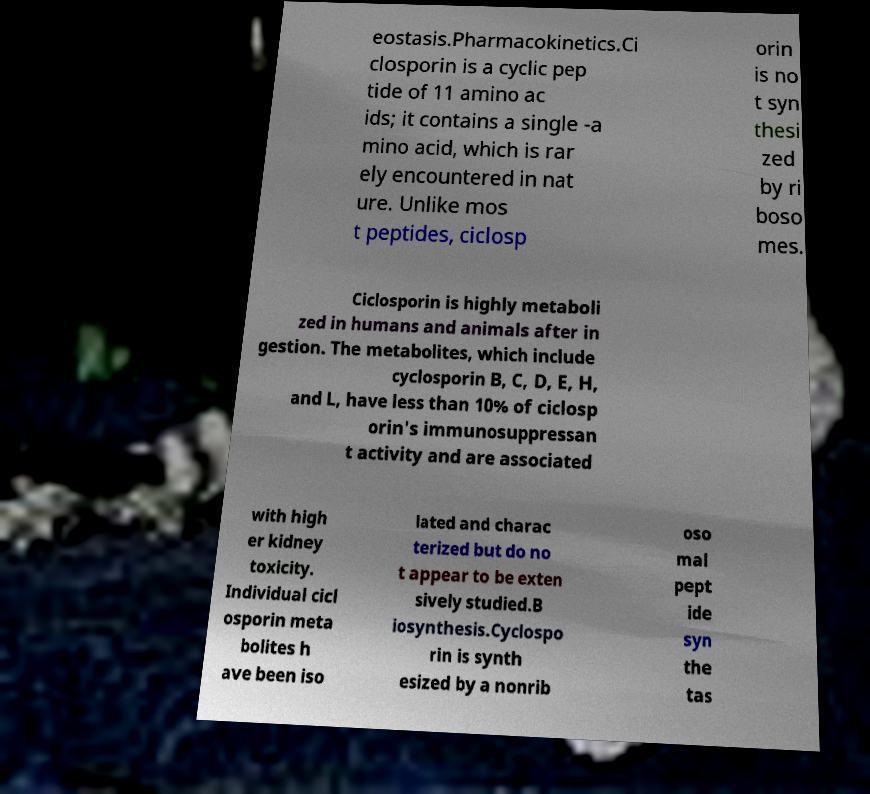There's text embedded in this image that I need extracted. Can you transcribe it verbatim? eostasis.Pharmacokinetics.Ci closporin is a cyclic pep tide of 11 amino ac ids; it contains a single -a mino acid, which is rar ely encountered in nat ure. Unlike mos t peptides, ciclosp orin is no t syn thesi zed by ri boso mes. Ciclosporin is highly metaboli zed in humans and animals after in gestion. The metabolites, which include cyclosporin B, C, D, E, H, and L, have less than 10% of ciclosp orin's immunosuppressan t activity and are associated with high er kidney toxicity. Individual cicl osporin meta bolites h ave been iso lated and charac terized but do no t appear to be exten sively studied.B iosynthesis.Cyclospo rin is synth esized by a nonrib oso mal pept ide syn the tas 